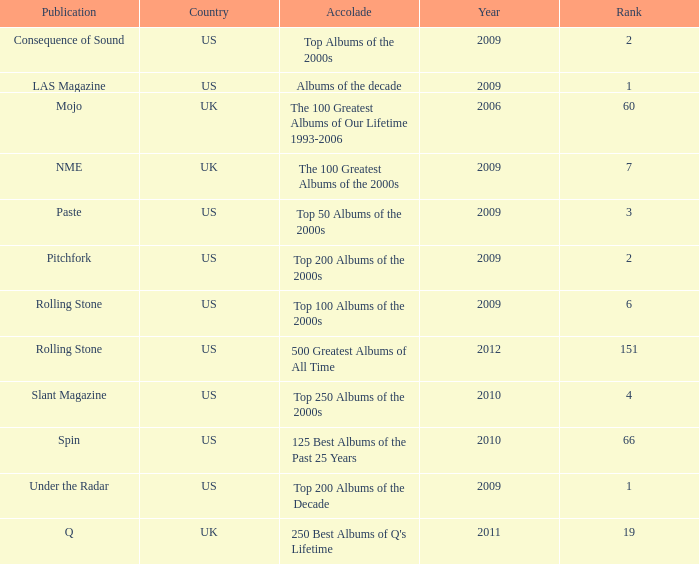What was the minimum position following 2009 with a recognition of 125 top albums of the previous 25 years? 66.0. 